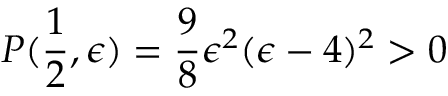Convert formula to latex. <formula><loc_0><loc_0><loc_500><loc_500>P ( \frac { 1 } { 2 } , \epsilon ) = \frac { 9 } { 8 } \epsilon ^ { 2 } ( \epsilon - 4 ) ^ { 2 } > 0</formula> 